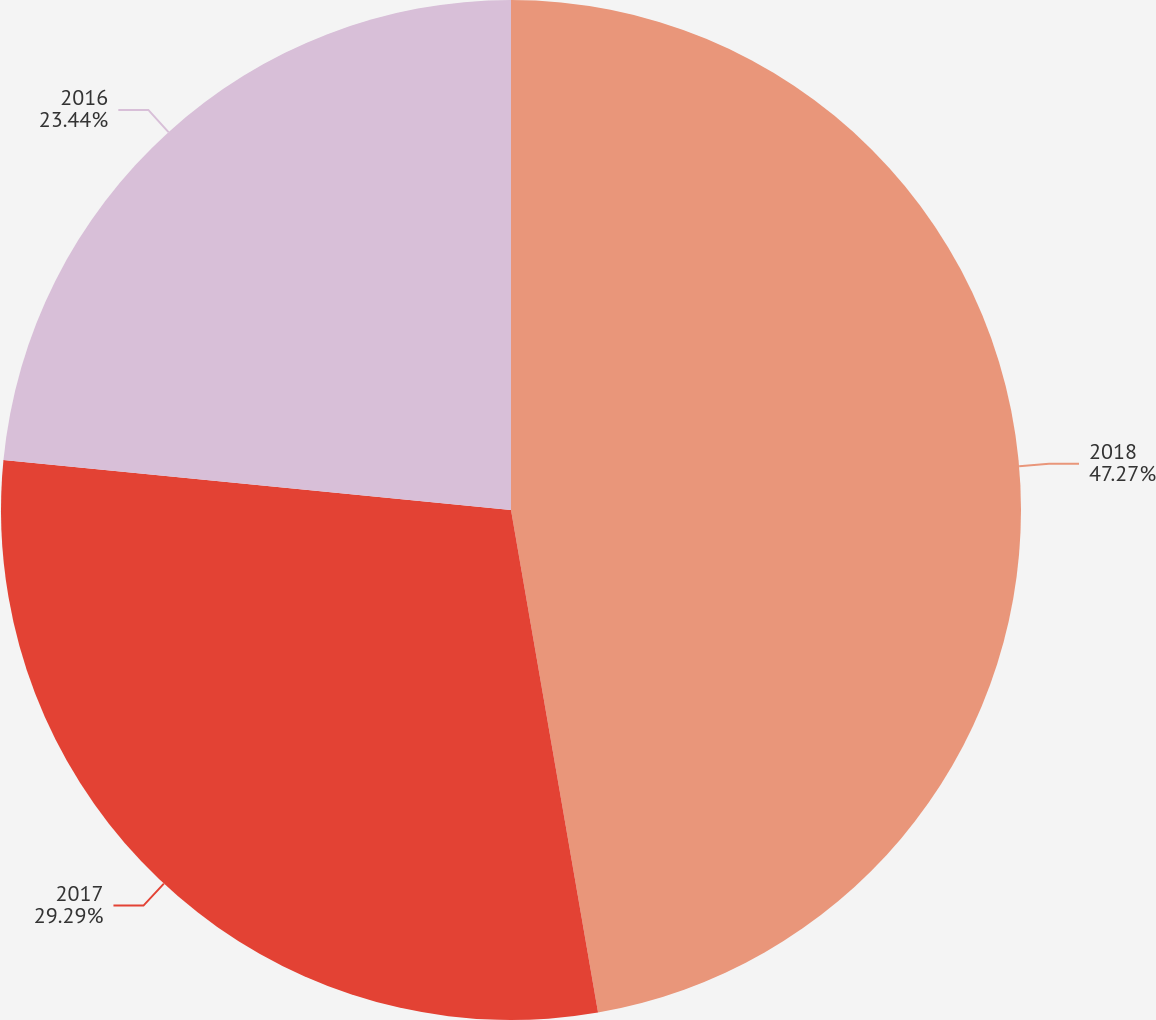<chart> <loc_0><loc_0><loc_500><loc_500><pie_chart><fcel>2018<fcel>2017<fcel>2016<nl><fcel>47.27%<fcel>29.29%<fcel>23.44%<nl></chart> 